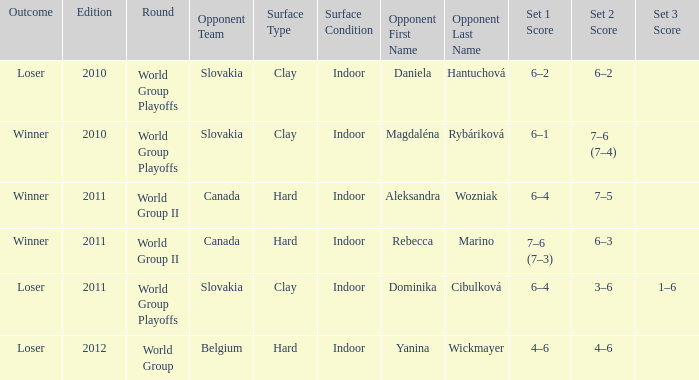How many outcomes were there when the opponent was Aleksandra Wozniak? 1.0. 